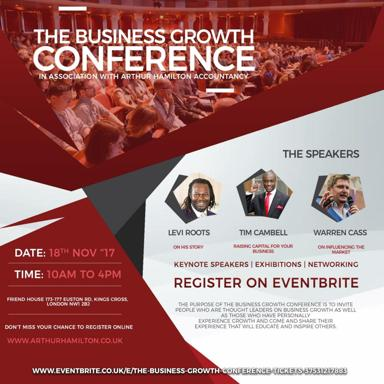Who are some of the speakers mentioned in the image? The prominent speakers listed for The Business Growth Conference include Levi Roots, known for his culinary entrepreneurship; Tim Cambell, noted for his investment insights; and Warren Cass, specializing in marketing strategies. These speakers bring a wealth of expertise in business innovation and growth. 